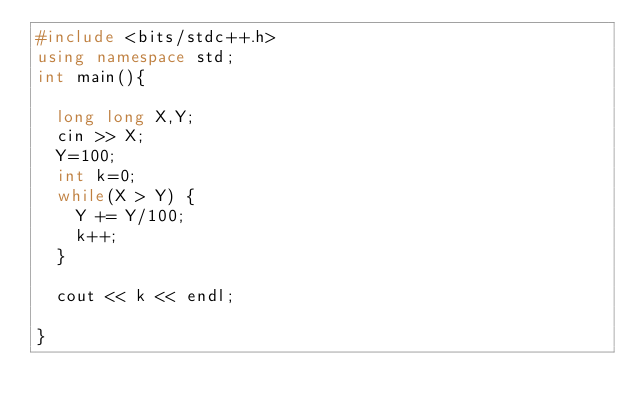<code> <loc_0><loc_0><loc_500><loc_500><_C++_>#include <bits/stdc++.h>
using namespace std;
int main(){
  
  long long X,Y;
  cin >> X;
  Y=100;
  int k=0;
  while(X > Y) {
    Y += Y/100;
    k++;
  }
  
  cout << k << endl;
  
}</code> 